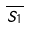<formula> <loc_0><loc_0><loc_500><loc_500>\overline { S _ { 1 } }</formula> 